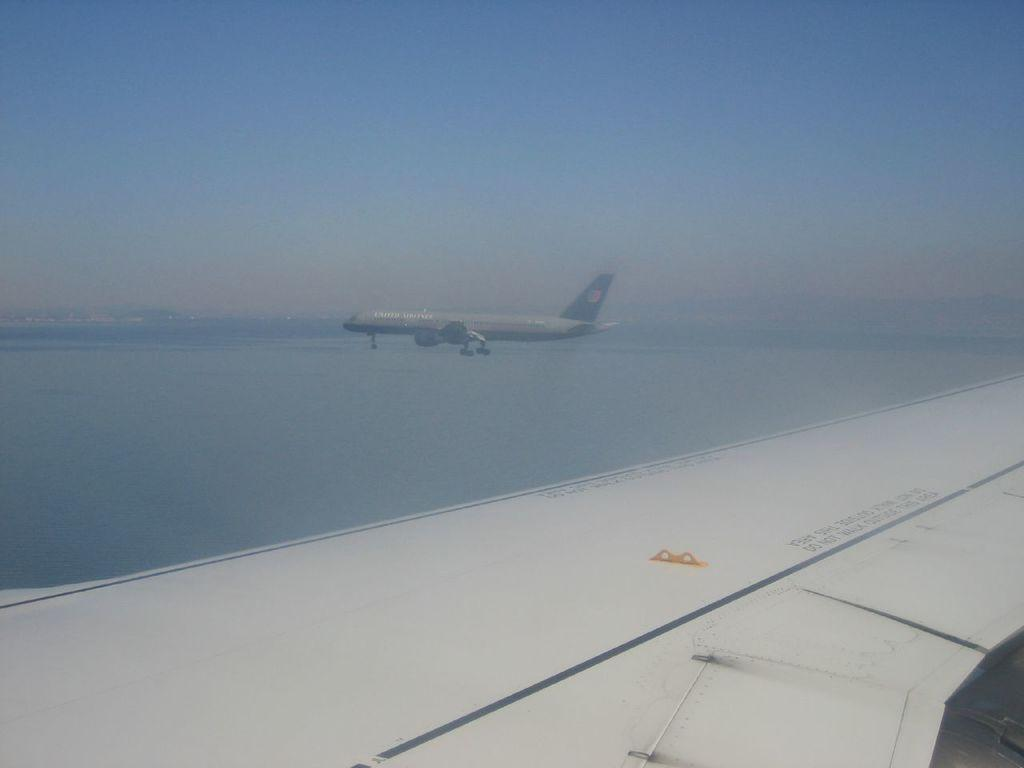What is the main subject of the image? The main subject of the image is an aeroplane. What color is the bottom part of the image? The bottom of the image is white. Are there any words or letters in the image? Yes, there is text visible in the image. What can be seen in the background of the image? There is water and the sky visible in the background of the image. How does the daughter help the beginner crow in the image? There is no daughter, beginner, or crow present in the image. 